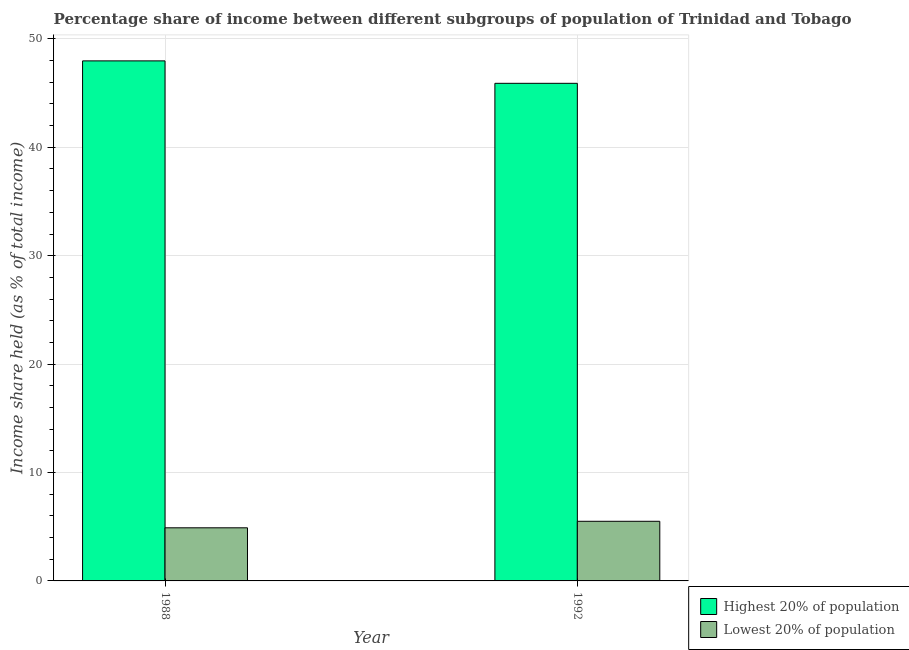How many different coloured bars are there?
Your answer should be very brief. 2. How many groups of bars are there?
Keep it short and to the point. 2. Are the number of bars per tick equal to the number of legend labels?
Your answer should be compact. Yes. In how many cases, is the number of bars for a given year not equal to the number of legend labels?
Offer a very short reply. 0. What is the income share held by highest 20% of the population in 1988?
Your response must be concise. 47.97. Across all years, what is the minimum income share held by highest 20% of the population?
Your answer should be compact. 45.9. What is the difference between the income share held by highest 20% of the population in 1988 and that in 1992?
Your answer should be very brief. 2.07. What is the difference between the income share held by lowest 20% of the population in 1988 and the income share held by highest 20% of the population in 1992?
Your answer should be very brief. -0.6. In the year 1988, what is the difference between the income share held by lowest 20% of the population and income share held by highest 20% of the population?
Give a very brief answer. 0. In how many years, is the income share held by lowest 20% of the population greater than 4 %?
Your answer should be compact. 2. What is the ratio of the income share held by lowest 20% of the population in 1988 to that in 1992?
Your answer should be compact. 0.89. Is the income share held by highest 20% of the population in 1988 less than that in 1992?
Keep it short and to the point. No. In how many years, is the income share held by highest 20% of the population greater than the average income share held by highest 20% of the population taken over all years?
Your response must be concise. 1. What does the 2nd bar from the left in 1988 represents?
Offer a very short reply. Lowest 20% of population. What does the 2nd bar from the right in 1988 represents?
Your answer should be very brief. Highest 20% of population. How many bars are there?
Ensure brevity in your answer.  4. Are the values on the major ticks of Y-axis written in scientific E-notation?
Your answer should be very brief. No. How many legend labels are there?
Offer a terse response. 2. How are the legend labels stacked?
Your response must be concise. Vertical. What is the title of the graph?
Provide a succinct answer. Percentage share of income between different subgroups of population of Trinidad and Tobago. Does "Urban Population" appear as one of the legend labels in the graph?
Your answer should be compact. No. What is the label or title of the X-axis?
Offer a very short reply. Year. What is the label or title of the Y-axis?
Give a very brief answer. Income share held (as % of total income). What is the Income share held (as % of total income) of Highest 20% of population in 1988?
Keep it short and to the point. 47.97. What is the Income share held (as % of total income) of Lowest 20% of population in 1988?
Your response must be concise. 4.9. What is the Income share held (as % of total income) of Highest 20% of population in 1992?
Make the answer very short. 45.9. What is the Income share held (as % of total income) in Lowest 20% of population in 1992?
Your answer should be compact. 5.5. Across all years, what is the maximum Income share held (as % of total income) in Highest 20% of population?
Make the answer very short. 47.97. Across all years, what is the maximum Income share held (as % of total income) in Lowest 20% of population?
Make the answer very short. 5.5. Across all years, what is the minimum Income share held (as % of total income) in Highest 20% of population?
Offer a terse response. 45.9. What is the total Income share held (as % of total income) of Highest 20% of population in the graph?
Your answer should be very brief. 93.87. What is the total Income share held (as % of total income) of Lowest 20% of population in the graph?
Provide a succinct answer. 10.4. What is the difference between the Income share held (as % of total income) of Highest 20% of population in 1988 and that in 1992?
Your answer should be compact. 2.07. What is the difference between the Income share held (as % of total income) of Highest 20% of population in 1988 and the Income share held (as % of total income) of Lowest 20% of population in 1992?
Your answer should be very brief. 42.47. What is the average Income share held (as % of total income) in Highest 20% of population per year?
Your answer should be compact. 46.94. What is the average Income share held (as % of total income) in Lowest 20% of population per year?
Offer a very short reply. 5.2. In the year 1988, what is the difference between the Income share held (as % of total income) of Highest 20% of population and Income share held (as % of total income) of Lowest 20% of population?
Your answer should be very brief. 43.07. In the year 1992, what is the difference between the Income share held (as % of total income) in Highest 20% of population and Income share held (as % of total income) in Lowest 20% of population?
Make the answer very short. 40.4. What is the ratio of the Income share held (as % of total income) of Highest 20% of population in 1988 to that in 1992?
Offer a terse response. 1.05. What is the ratio of the Income share held (as % of total income) in Lowest 20% of population in 1988 to that in 1992?
Ensure brevity in your answer.  0.89. What is the difference between the highest and the second highest Income share held (as % of total income) in Highest 20% of population?
Offer a very short reply. 2.07. What is the difference between the highest and the second highest Income share held (as % of total income) of Lowest 20% of population?
Your answer should be compact. 0.6. What is the difference between the highest and the lowest Income share held (as % of total income) in Highest 20% of population?
Provide a short and direct response. 2.07. 